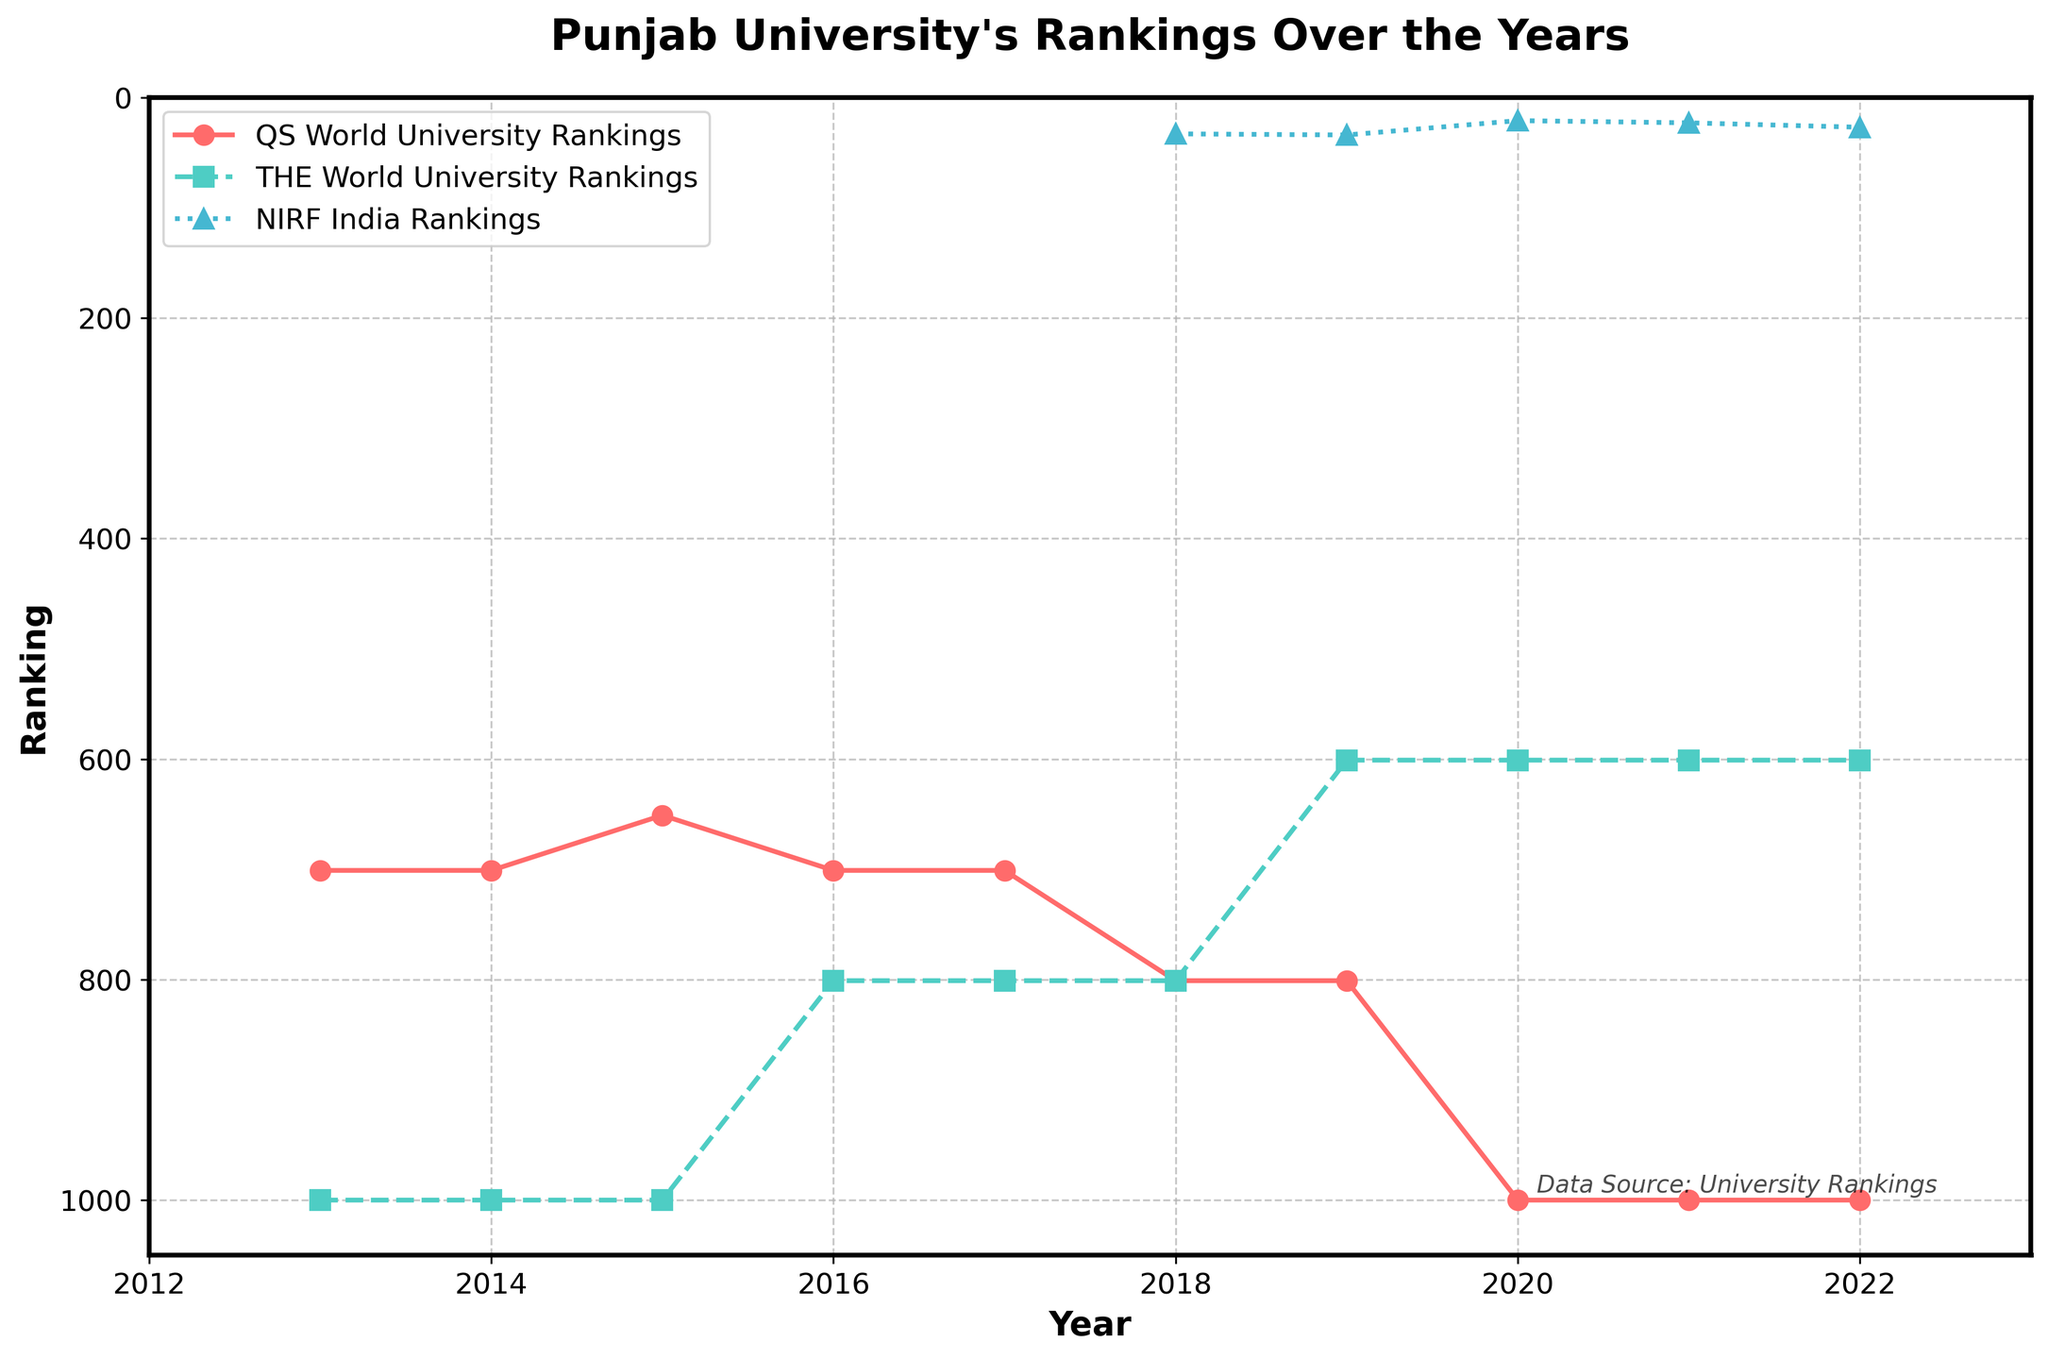What is the most recent QS World University Ranking for Punjab University? The most recent QS World University Ranking, according to the figure, is for the year 2022. The plot shows that Punjab University is ranked 1001+ in 2022.
Answer: 1001+ Which year did Punjab University achieve its best QS World University Ranking, and what was the ranking? The plot shows the QS World University Rankings for different years. The year Punjab University achieved its best ranking was in 2015, and the ranking was 651-700.
Answer: 2015, 651-700 In which year did Punjab University first appear in the NIRF India Rankings, and what was its ranking? The NIRF India Rankings line marks the appearances of Punjab University. The first appearance was in the year 2018 with a ranking of 33.
Answer: 2018, 33 Compare the 2020 THE World University Ranking with the 2022 QS World University Ranking. Which one is better? The 2020 THE World University Ranking is 601-800, and the 2022 QS World University Ranking is 1001+. Since a lower ranking number is better, the 2020 THE World University Ranking is better than the 2022 QS World University Ranking.
Answer: 2020 THE World University Ranking How has Punjab University's ranking in the NIRF India Rankings changed from 2018 to 2022? The NIRF India Rankings line shows the progression from 2018 to 2022: 33 (2018), 34 (2019), 21 (2020), 23 (2021), and 27 (2022).
Answer: Improved initially and then declined What visual attribute helps to identify the QS World University Rankings in the plot? The QS World University Rankings line is identified by the color red, and the markers are circles ('o'). This visual attribute helps in distinguishing it from other rankings.
Answer: Red color, circle markers Which ranking shows the greatest variation over the years? By observing the lines on the plot, the THE World University Rankings line shows significant variation, moving from "Not Ranked" to the 801-1000 range and then improving to the 601-800 range.
Answer: THE World University Rankings Which years had Punjab University positioned similarly in both THE World University Rankings and QS World University Rankings? The plot shows that during the years 2018 and 2019, both THE and QS rankings placed Punjab University within the 801-1000 range.
Answer: 2018, 2019 Which year had the largest disparity between QS World University Rankings and THE World University Rankings? In 2020, the QS World University Rankings were in the 1001+ range, while THE World University Rankings were in the 601-800 range, showing the largest disparity.
Answer: 2020 During which years did Punjab University see an improvement in its THE World University Ranking? The THE World University Rankings show improvement from 801-1000 (2017) to 601-800 (2019), and it remained the same from 2019 to 2022.
Answer: 2019 